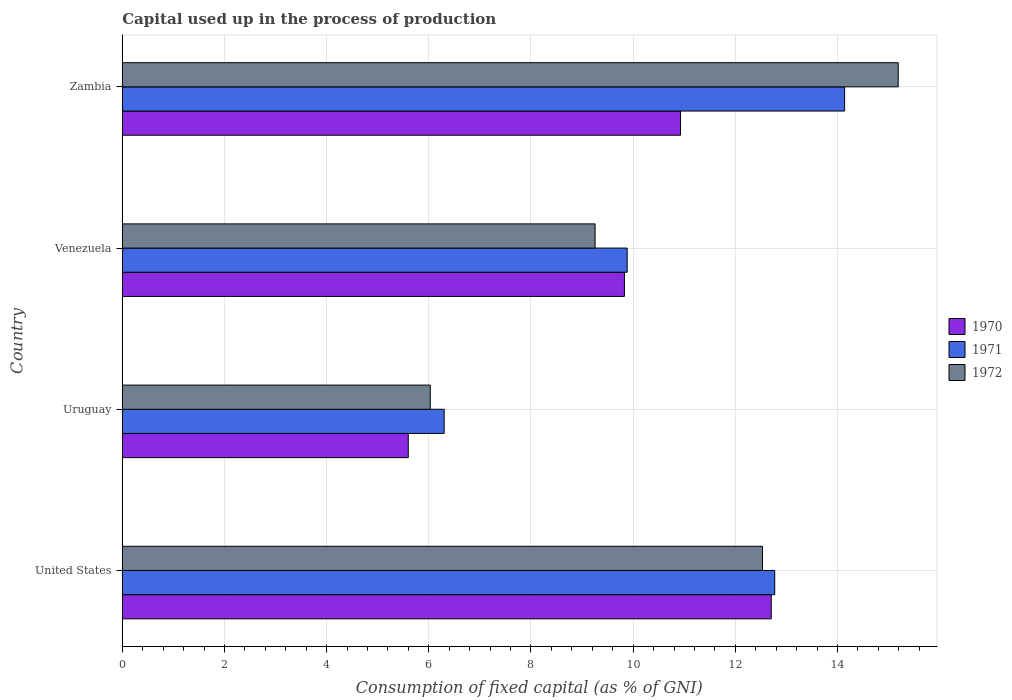How many different coloured bars are there?
Make the answer very short. 3. Are the number of bars per tick equal to the number of legend labels?
Offer a very short reply. Yes. What is the label of the 1st group of bars from the top?
Provide a short and direct response. Zambia. What is the capital used up in the process of production in 1970 in United States?
Your answer should be very brief. 12.7. Across all countries, what is the maximum capital used up in the process of production in 1971?
Offer a terse response. 14.14. Across all countries, what is the minimum capital used up in the process of production in 1971?
Your answer should be compact. 6.3. In which country was the capital used up in the process of production in 1972 maximum?
Keep it short and to the point. Zambia. In which country was the capital used up in the process of production in 1972 minimum?
Provide a succinct answer. Uruguay. What is the total capital used up in the process of production in 1970 in the graph?
Offer a terse response. 39.06. What is the difference between the capital used up in the process of production in 1971 in Venezuela and that in Zambia?
Offer a terse response. -4.26. What is the difference between the capital used up in the process of production in 1970 in United States and the capital used up in the process of production in 1971 in Zambia?
Offer a terse response. -1.44. What is the average capital used up in the process of production in 1972 per country?
Keep it short and to the point. 10.75. What is the difference between the capital used up in the process of production in 1972 and capital used up in the process of production in 1971 in Venezuela?
Ensure brevity in your answer.  -0.63. What is the ratio of the capital used up in the process of production in 1972 in United States to that in Zambia?
Provide a short and direct response. 0.83. What is the difference between the highest and the second highest capital used up in the process of production in 1971?
Offer a very short reply. 1.37. What is the difference between the highest and the lowest capital used up in the process of production in 1971?
Offer a very short reply. 7.84. What does the 1st bar from the top in Venezuela represents?
Provide a succinct answer. 1972. Is it the case that in every country, the sum of the capital used up in the process of production in 1972 and capital used up in the process of production in 1971 is greater than the capital used up in the process of production in 1970?
Offer a terse response. Yes. Are all the bars in the graph horizontal?
Your response must be concise. Yes. What is the difference between two consecutive major ticks on the X-axis?
Offer a very short reply. 2. Are the values on the major ticks of X-axis written in scientific E-notation?
Your answer should be compact. No. Does the graph contain any zero values?
Offer a terse response. No. Does the graph contain grids?
Offer a very short reply. Yes. What is the title of the graph?
Give a very brief answer. Capital used up in the process of production. Does "1998" appear as one of the legend labels in the graph?
Your answer should be compact. No. What is the label or title of the X-axis?
Offer a very short reply. Consumption of fixed capital (as % of GNI). What is the Consumption of fixed capital (as % of GNI) of 1970 in United States?
Offer a very short reply. 12.7. What is the Consumption of fixed capital (as % of GNI) in 1971 in United States?
Your answer should be very brief. 12.77. What is the Consumption of fixed capital (as % of GNI) of 1972 in United States?
Offer a terse response. 12.53. What is the Consumption of fixed capital (as % of GNI) in 1970 in Uruguay?
Provide a succinct answer. 5.6. What is the Consumption of fixed capital (as % of GNI) in 1971 in Uruguay?
Your answer should be compact. 6.3. What is the Consumption of fixed capital (as % of GNI) in 1972 in Uruguay?
Your answer should be compact. 6.03. What is the Consumption of fixed capital (as % of GNI) in 1970 in Venezuela?
Offer a terse response. 9.83. What is the Consumption of fixed capital (as % of GNI) in 1971 in Venezuela?
Your answer should be compact. 9.88. What is the Consumption of fixed capital (as % of GNI) in 1972 in Venezuela?
Give a very brief answer. 9.25. What is the Consumption of fixed capital (as % of GNI) in 1970 in Zambia?
Your response must be concise. 10.93. What is the Consumption of fixed capital (as % of GNI) in 1971 in Zambia?
Your answer should be very brief. 14.14. What is the Consumption of fixed capital (as % of GNI) of 1972 in Zambia?
Offer a terse response. 15.19. Across all countries, what is the maximum Consumption of fixed capital (as % of GNI) of 1970?
Provide a succinct answer. 12.7. Across all countries, what is the maximum Consumption of fixed capital (as % of GNI) of 1971?
Make the answer very short. 14.14. Across all countries, what is the maximum Consumption of fixed capital (as % of GNI) in 1972?
Offer a very short reply. 15.19. Across all countries, what is the minimum Consumption of fixed capital (as % of GNI) in 1970?
Offer a very short reply. 5.6. Across all countries, what is the minimum Consumption of fixed capital (as % of GNI) of 1971?
Your answer should be very brief. 6.3. Across all countries, what is the minimum Consumption of fixed capital (as % of GNI) in 1972?
Make the answer very short. 6.03. What is the total Consumption of fixed capital (as % of GNI) in 1970 in the graph?
Your response must be concise. 39.06. What is the total Consumption of fixed capital (as % of GNI) of 1971 in the graph?
Make the answer very short. 43.09. What is the total Consumption of fixed capital (as % of GNI) in 1972 in the graph?
Provide a short and direct response. 43. What is the difference between the Consumption of fixed capital (as % of GNI) in 1970 in United States and that in Uruguay?
Offer a very short reply. 7.11. What is the difference between the Consumption of fixed capital (as % of GNI) in 1971 in United States and that in Uruguay?
Give a very brief answer. 6.47. What is the difference between the Consumption of fixed capital (as % of GNI) of 1972 in United States and that in Uruguay?
Your response must be concise. 6.5. What is the difference between the Consumption of fixed capital (as % of GNI) of 1970 in United States and that in Venezuela?
Keep it short and to the point. 2.87. What is the difference between the Consumption of fixed capital (as % of GNI) in 1971 in United States and that in Venezuela?
Your answer should be compact. 2.89. What is the difference between the Consumption of fixed capital (as % of GNI) in 1972 in United States and that in Venezuela?
Provide a short and direct response. 3.28. What is the difference between the Consumption of fixed capital (as % of GNI) of 1970 in United States and that in Zambia?
Provide a short and direct response. 1.78. What is the difference between the Consumption of fixed capital (as % of GNI) of 1971 in United States and that in Zambia?
Ensure brevity in your answer.  -1.37. What is the difference between the Consumption of fixed capital (as % of GNI) in 1972 in United States and that in Zambia?
Make the answer very short. -2.66. What is the difference between the Consumption of fixed capital (as % of GNI) of 1970 in Uruguay and that in Venezuela?
Ensure brevity in your answer.  -4.23. What is the difference between the Consumption of fixed capital (as % of GNI) of 1971 in Uruguay and that in Venezuela?
Provide a succinct answer. -3.58. What is the difference between the Consumption of fixed capital (as % of GNI) in 1972 in Uruguay and that in Venezuela?
Give a very brief answer. -3.23. What is the difference between the Consumption of fixed capital (as % of GNI) in 1970 in Uruguay and that in Zambia?
Your answer should be compact. -5.33. What is the difference between the Consumption of fixed capital (as % of GNI) of 1971 in Uruguay and that in Zambia?
Provide a short and direct response. -7.84. What is the difference between the Consumption of fixed capital (as % of GNI) in 1972 in Uruguay and that in Zambia?
Your response must be concise. -9.16. What is the difference between the Consumption of fixed capital (as % of GNI) of 1970 in Venezuela and that in Zambia?
Keep it short and to the point. -1.1. What is the difference between the Consumption of fixed capital (as % of GNI) in 1971 in Venezuela and that in Zambia?
Ensure brevity in your answer.  -4.26. What is the difference between the Consumption of fixed capital (as % of GNI) in 1972 in Venezuela and that in Zambia?
Offer a terse response. -5.93. What is the difference between the Consumption of fixed capital (as % of GNI) of 1970 in United States and the Consumption of fixed capital (as % of GNI) of 1971 in Uruguay?
Ensure brevity in your answer.  6.4. What is the difference between the Consumption of fixed capital (as % of GNI) in 1970 in United States and the Consumption of fixed capital (as % of GNI) in 1972 in Uruguay?
Offer a very short reply. 6.67. What is the difference between the Consumption of fixed capital (as % of GNI) in 1971 in United States and the Consumption of fixed capital (as % of GNI) in 1972 in Uruguay?
Give a very brief answer. 6.74. What is the difference between the Consumption of fixed capital (as % of GNI) of 1970 in United States and the Consumption of fixed capital (as % of GNI) of 1971 in Venezuela?
Give a very brief answer. 2.82. What is the difference between the Consumption of fixed capital (as % of GNI) of 1970 in United States and the Consumption of fixed capital (as % of GNI) of 1972 in Venezuela?
Your answer should be very brief. 3.45. What is the difference between the Consumption of fixed capital (as % of GNI) of 1971 in United States and the Consumption of fixed capital (as % of GNI) of 1972 in Venezuela?
Give a very brief answer. 3.52. What is the difference between the Consumption of fixed capital (as % of GNI) in 1970 in United States and the Consumption of fixed capital (as % of GNI) in 1971 in Zambia?
Keep it short and to the point. -1.44. What is the difference between the Consumption of fixed capital (as % of GNI) of 1970 in United States and the Consumption of fixed capital (as % of GNI) of 1972 in Zambia?
Make the answer very short. -2.48. What is the difference between the Consumption of fixed capital (as % of GNI) of 1971 in United States and the Consumption of fixed capital (as % of GNI) of 1972 in Zambia?
Your answer should be very brief. -2.42. What is the difference between the Consumption of fixed capital (as % of GNI) of 1970 in Uruguay and the Consumption of fixed capital (as % of GNI) of 1971 in Venezuela?
Keep it short and to the point. -4.28. What is the difference between the Consumption of fixed capital (as % of GNI) of 1970 in Uruguay and the Consumption of fixed capital (as % of GNI) of 1972 in Venezuela?
Make the answer very short. -3.66. What is the difference between the Consumption of fixed capital (as % of GNI) of 1971 in Uruguay and the Consumption of fixed capital (as % of GNI) of 1972 in Venezuela?
Your response must be concise. -2.95. What is the difference between the Consumption of fixed capital (as % of GNI) of 1970 in Uruguay and the Consumption of fixed capital (as % of GNI) of 1971 in Zambia?
Provide a short and direct response. -8.54. What is the difference between the Consumption of fixed capital (as % of GNI) of 1970 in Uruguay and the Consumption of fixed capital (as % of GNI) of 1972 in Zambia?
Your answer should be very brief. -9.59. What is the difference between the Consumption of fixed capital (as % of GNI) of 1971 in Uruguay and the Consumption of fixed capital (as % of GNI) of 1972 in Zambia?
Provide a short and direct response. -8.89. What is the difference between the Consumption of fixed capital (as % of GNI) of 1970 in Venezuela and the Consumption of fixed capital (as % of GNI) of 1971 in Zambia?
Offer a terse response. -4.31. What is the difference between the Consumption of fixed capital (as % of GNI) of 1970 in Venezuela and the Consumption of fixed capital (as % of GNI) of 1972 in Zambia?
Offer a terse response. -5.36. What is the difference between the Consumption of fixed capital (as % of GNI) of 1971 in Venezuela and the Consumption of fixed capital (as % of GNI) of 1972 in Zambia?
Provide a short and direct response. -5.31. What is the average Consumption of fixed capital (as % of GNI) of 1970 per country?
Ensure brevity in your answer.  9.76. What is the average Consumption of fixed capital (as % of GNI) in 1971 per country?
Give a very brief answer. 10.77. What is the average Consumption of fixed capital (as % of GNI) in 1972 per country?
Offer a terse response. 10.75. What is the difference between the Consumption of fixed capital (as % of GNI) in 1970 and Consumption of fixed capital (as % of GNI) in 1971 in United States?
Your response must be concise. -0.07. What is the difference between the Consumption of fixed capital (as % of GNI) in 1970 and Consumption of fixed capital (as % of GNI) in 1972 in United States?
Provide a succinct answer. 0.17. What is the difference between the Consumption of fixed capital (as % of GNI) of 1971 and Consumption of fixed capital (as % of GNI) of 1972 in United States?
Your answer should be very brief. 0.24. What is the difference between the Consumption of fixed capital (as % of GNI) of 1970 and Consumption of fixed capital (as % of GNI) of 1971 in Uruguay?
Your answer should be very brief. -0.7. What is the difference between the Consumption of fixed capital (as % of GNI) of 1970 and Consumption of fixed capital (as % of GNI) of 1972 in Uruguay?
Your answer should be very brief. -0.43. What is the difference between the Consumption of fixed capital (as % of GNI) of 1971 and Consumption of fixed capital (as % of GNI) of 1972 in Uruguay?
Ensure brevity in your answer.  0.27. What is the difference between the Consumption of fixed capital (as % of GNI) in 1970 and Consumption of fixed capital (as % of GNI) in 1971 in Venezuela?
Provide a succinct answer. -0.05. What is the difference between the Consumption of fixed capital (as % of GNI) in 1970 and Consumption of fixed capital (as % of GNI) in 1972 in Venezuela?
Provide a short and direct response. 0.57. What is the difference between the Consumption of fixed capital (as % of GNI) in 1971 and Consumption of fixed capital (as % of GNI) in 1972 in Venezuela?
Make the answer very short. 0.63. What is the difference between the Consumption of fixed capital (as % of GNI) of 1970 and Consumption of fixed capital (as % of GNI) of 1971 in Zambia?
Ensure brevity in your answer.  -3.21. What is the difference between the Consumption of fixed capital (as % of GNI) in 1970 and Consumption of fixed capital (as % of GNI) in 1972 in Zambia?
Your answer should be very brief. -4.26. What is the difference between the Consumption of fixed capital (as % of GNI) in 1971 and Consumption of fixed capital (as % of GNI) in 1972 in Zambia?
Provide a short and direct response. -1.05. What is the ratio of the Consumption of fixed capital (as % of GNI) of 1970 in United States to that in Uruguay?
Give a very brief answer. 2.27. What is the ratio of the Consumption of fixed capital (as % of GNI) in 1971 in United States to that in Uruguay?
Offer a very short reply. 2.03. What is the ratio of the Consumption of fixed capital (as % of GNI) of 1972 in United States to that in Uruguay?
Offer a very short reply. 2.08. What is the ratio of the Consumption of fixed capital (as % of GNI) of 1970 in United States to that in Venezuela?
Make the answer very short. 1.29. What is the ratio of the Consumption of fixed capital (as % of GNI) of 1971 in United States to that in Venezuela?
Your answer should be compact. 1.29. What is the ratio of the Consumption of fixed capital (as % of GNI) of 1972 in United States to that in Venezuela?
Give a very brief answer. 1.35. What is the ratio of the Consumption of fixed capital (as % of GNI) of 1970 in United States to that in Zambia?
Ensure brevity in your answer.  1.16. What is the ratio of the Consumption of fixed capital (as % of GNI) in 1971 in United States to that in Zambia?
Offer a terse response. 0.9. What is the ratio of the Consumption of fixed capital (as % of GNI) in 1972 in United States to that in Zambia?
Provide a short and direct response. 0.83. What is the ratio of the Consumption of fixed capital (as % of GNI) in 1970 in Uruguay to that in Venezuela?
Give a very brief answer. 0.57. What is the ratio of the Consumption of fixed capital (as % of GNI) in 1971 in Uruguay to that in Venezuela?
Ensure brevity in your answer.  0.64. What is the ratio of the Consumption of fixed capital (as % of GNI) of 1972 in Uruguay to that in Venezuela?
Keep it short and to the point. 0.65. What is the ratio of the Consumption of fixed capital (as % of GNI) in 1970 in Uruguay to that in Zambia?
Your answer should be very brief. 0.51. What is the ratio of the Consumption of fixed capital (as % of GNI) in 1971 in Uruguay to that in Zambia?
Your answer should be very brief. 0.45. What is the ratio of the Consumption of fixed capital (as % of GNI) in 1972 in Uruguay to that in Zambia?
Your answer should be very brief. 0.4. What is the ratio of the Consumption of fixed capital (as % of GNI) of 1970 in Venezuela to that in Zambia?
Give a very brief answer. 0.9. What is the ratio of the Consumption of fixed capital (as % of GNI) in 1971 in Venezuela to that in Zambia?
Provide a succinct answer. 0.7. What is the ratio of the Consumption of fixed capital (as % of GNI) of 1972 in Venezuela to that in Zambia?
Give a very brief answer. 0.61. What is the difference between the highest and the second highest Consumption of fixed capital (as % of GNI) in 1970?
Your answer should be very brief. 1.78. What is the difference between the highest and the second highest Consumption of fixed capital (as % of GNI) of 1971?
Your response must be concise. 1.37. What is the difference between the highest and the second highest Consumption of fixed capital (as % of GNI) of 1972?
Your answer should be compact. 2.66. What is the difference between the highest and the lowest Consumption of fixed capital (as % of GNI) in 1970?
Provide a short and direct response. 7.11. What is the difference between the highest and the lowest Consumption of fixed capital (as % of GNI) in 1971?
Offer a very short reply. 7.84. What is the difference between the highest and the lowest Consumption of fixed capital (as % of GNI) in 1972?
Keep it short and to the point. 9.16. 